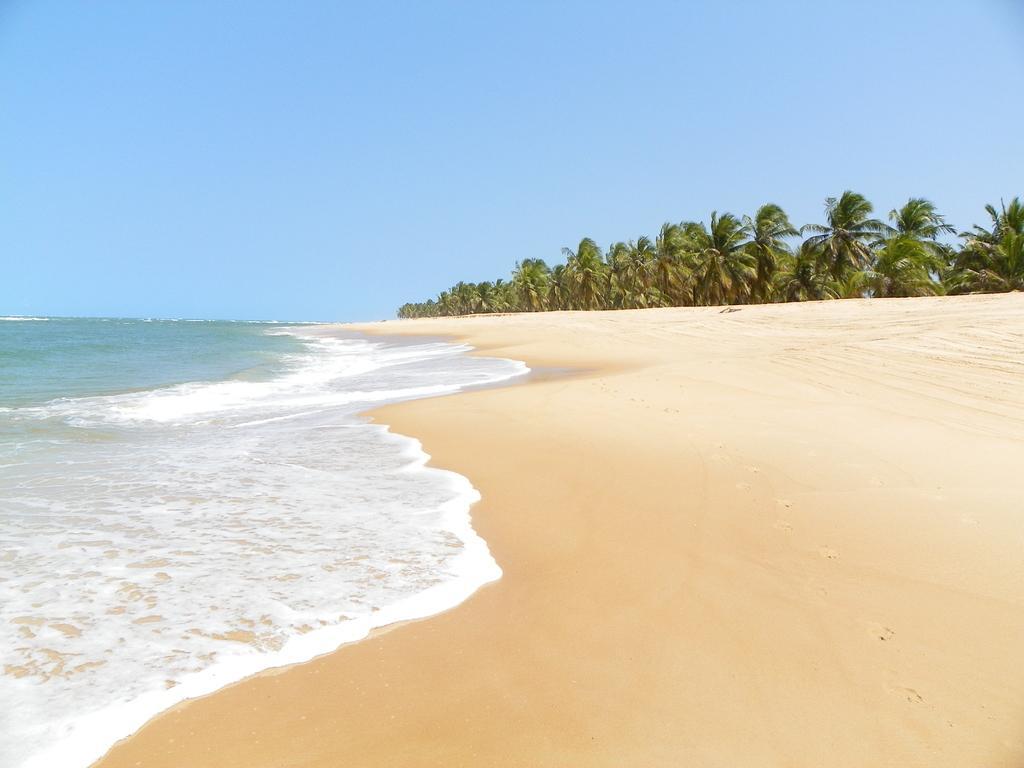Could you give a brief overview of what you see in this image? In this image, we can see a water and sand. Background there are so many trees and clear sky. 